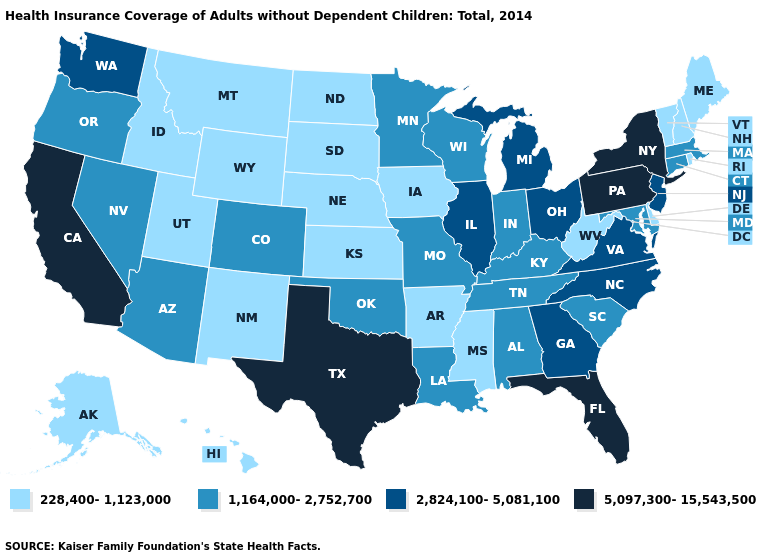What is the highest value in states that border South Carolina?
Be succinct. 2,824,100-5,081,100. Name the states that have a value in the range 1,164,000-2,752,700?
Quick response, please. Alabama, Arizona, Colorado, Connecticut, Indiana, Kentucky, Louisiana, Maryland, Massachusetts, Minnesota, Missouri, Nevada, Oklahoma, Oregon, South Carolina, Tennessee, Wisconsin. Name the states that have a value in the range 2,824,100-5,081,100?
Write a very short answer. Georgia, Illinois, Michigan, New Jersey, North Carolina, Ohio, Virginia, Washington. What is the value of Missouri?
Concise answer only. 1,164,000-2,752,700. Does Connecticut have the lowest value in the Northeast?
Keep it brief. No. What is the highest value in the USA?
Keep it brief. 5,097,300-15,543,500. What is the highest value in states that border Alabama?
Be succinct. 5,097,300-15,543,500. Name the states that have a value in the range 1,164,000-2,752,700?
Be succinct. Alabama, Arizona, Colorado, Connecticut, Indiana, Kentucky, Louisiana, Maryland, Massachusetts, Minnesota, Missouri, Nevada, Oklahoma, Oregon, South Carolina, Tennessee, Wisconsin. Name the states that have a value in the range 5,097,300-15,543,500?
Short answer required. California, Florida, New York, Pennsylvania, Texas. What is the value of Montana?
Be succinct. 228,400-1,123,000. What is the highest value in the USA?
Give a very brief answer. 5,097,300-15,543,500. Does Florida have the highest value in the South?
Short answer required. Yes. Does Wisconsin have a lower value than Oklahoma?
Answer briefly. No. Among the states that border Virginia , does Tennessee have the lowest value?
Answer briefly. No. What is the highest value in the MidWest ?
Answer briefly. 2,824,100-5,081,100. 